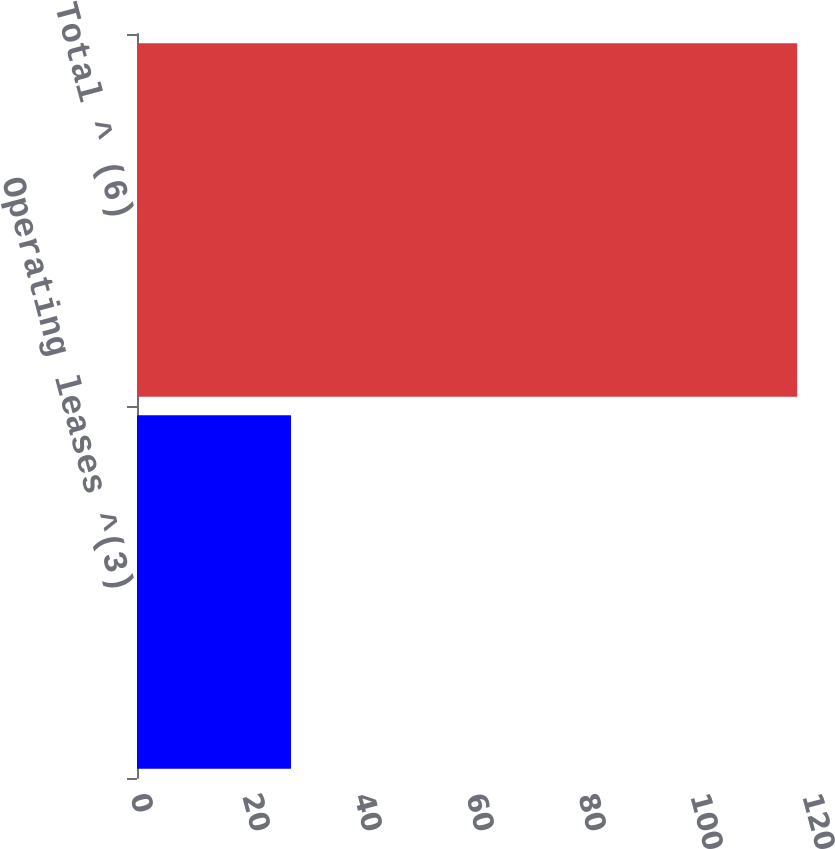Convert chart. <chart><loc_0><loc_0><loc_500><loc_500><bar_chart><fcel>Operating leases ^(3)<fcel>Total ^ (6)<nl><fcel>27.5<fcel>117.9<nl></chart> 